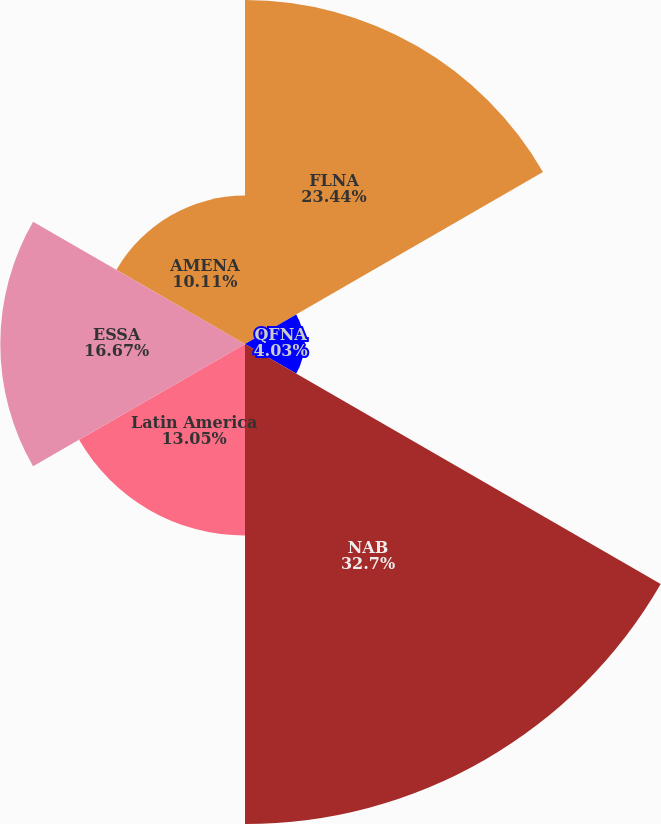Convert chart to OTSL. <chart><loc_0><loc_0><loc_500><loc_500><pie_chart><fcel>FLNA<fcel>QFNA<fcel>NAB<fcel>Latin America<fcel>ESSA<fcel>AMENA<nl><fcel>23.44%<fcel>4.03%<fcel>32.7%<fcel>13.05%<fcel>16.67%<fcel>10.11%<nl></chart> 